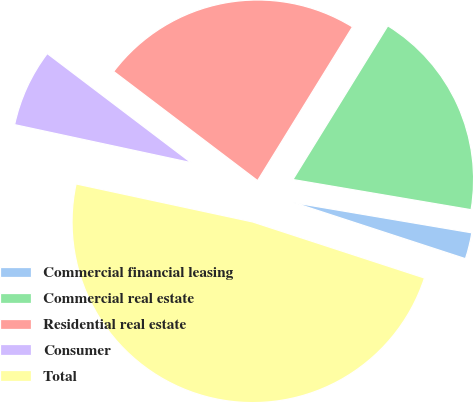<chart> <loc_0><loc_0><loc_500><loc_500><pie_chart><fcel>Commercial financial leasing<fcel>Commercial real estate<fcel>Residential real estate<fcel>Consumer<fcel>Total<nl><fcel>2.35%<fcel>18.87%<fcel>23.47%<fcel>6.95%<fcel>48.35%<nl></chart> 